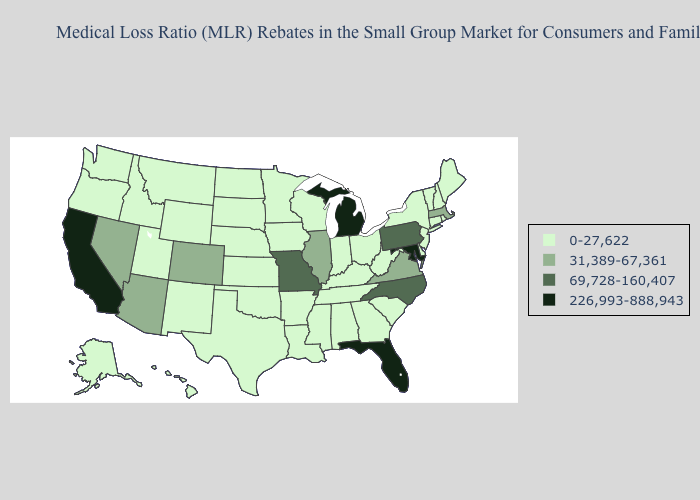What is the value of Illinois?
Quick response, please. 31,389-67,361. What is the highest value in states that border Massachusetts?
Give a very brief answer. 0-27,622. Does Virginia have the lowest value in the South?
Write a very short answer. No. What is the lowest value in states that border Colorado?
Answer briefly. 0-27,622. Among the states that border Idaho , which have the lowest value?
Give a very brief answer. Montana, Oregon, Utah, Washington, Wyoming. What is the lowest value in the USA?
Write a very short answer. 0-27,622. What is the value of South Carolina?
Keep it brief. 0-27,622. Is the legend a continuous bar?
Quick response, please. No. Name the states that have a value in the range 69,728-160,407?
Concise answer only. Missouri, North Carolina, Pennsylvania. What is the highest value in the USA?
Write a very short answer. 226,993-888,943. Name the states that have a value in the range 69,728-160,407?
Answer briefly. Missouri, North Carolina, Pennsylvania. What is the highest value in the USA?
Keep it brief. 226,993-888,943. What is the value of North Dakota?
Keep it brief. 0-27,622. What is the value of Wyoming?
Be succinct. 0-27,622. Name the states that have a value in the range 31,389-67,361?
Be succinct. Arizona, Colorado, Illinois, Massachusetts, Nevada, Virginia. 